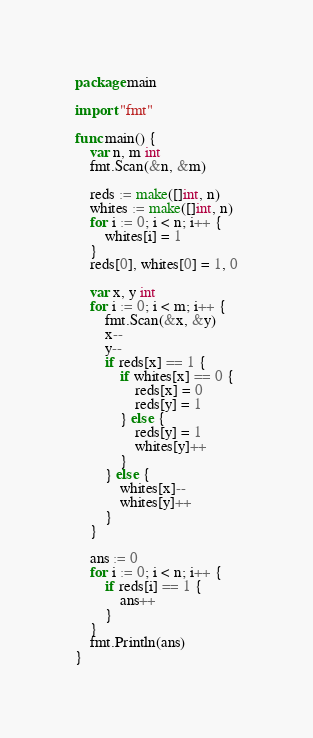Convert code to text. <code><loc_0><loc_0><loc_500><loc_500><_Go_>package main

import "fmt"

func main() {
	var n, m int
	fmt.Scan(&n, &m)

	reds := make([]int, n)
	whites := make([]int, n)
	for i := 0; i < n; i++ {
		whites[i] = 1
	}
	reds[0], whites[0] = 1, 0

	var x, y int
	for i := 0; i < m; i++ {
		fmt.Scan(&x, &y)
		x--
		y--
		if reds[x] == 1 {
			if whites[x] == 0 {
				reds[x] = 0
				reds[y] = 1
			} else {
				reds[y] = 1
				whites[y]++
			}
		} else {
			whites[x]--
			whites[y]++
		}
	}

	ans := 0
	for i := 0; i < n; i++ {
		if reds[i] == 1 {
			ans++
		}
	}
	fmt.Println(ans)
}
</code> 